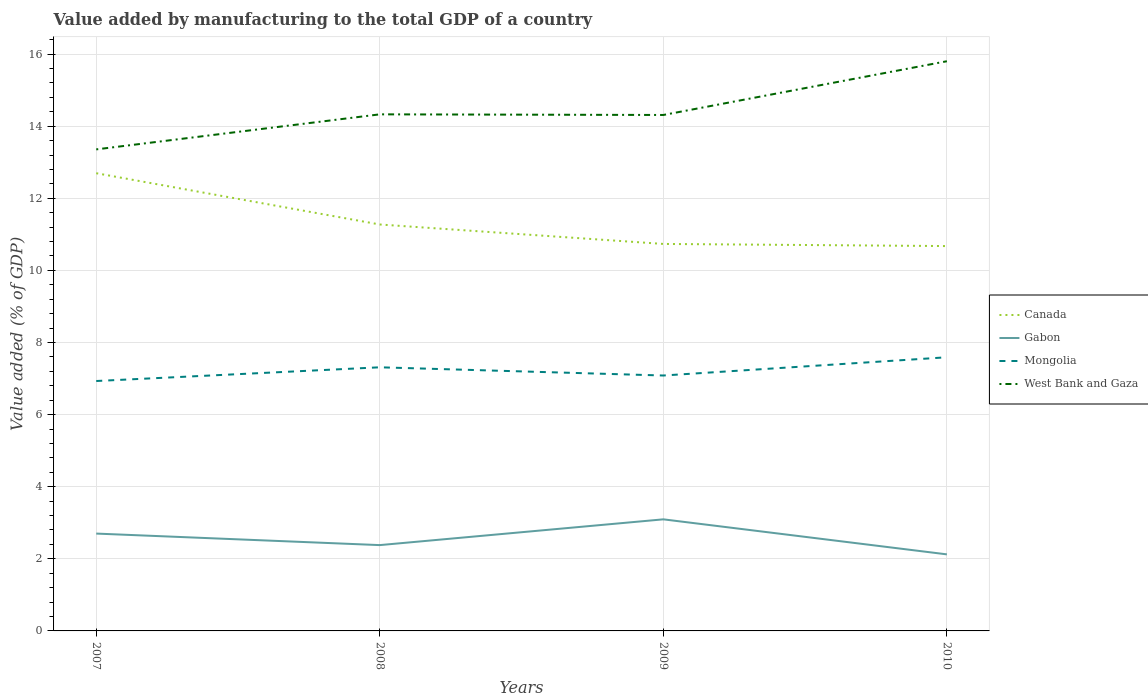How many different coloured lines are there?
Offer a terse response. 4. Across all years, what is the maximum value added by manufacturing to the total GDP in West Bank and Gaza?
Offer a very short reply. 13.36. In which year was the value added by manufacturing to the total GDP in Mongolia maximum?
Make the answer very short. 2007. What is the total value added by manufacturing to the total GDP in West Bank and Gaza in the graph?
Ensure brevity in your answer.  -2.45. What is the difference between the highest and the second highest value added by manufacturing to the total GDP in Gabon?
Ensure brevity in your answer.  0.97. What is the difference between the highest and the lowest value added by manufacturing to the total GDP in West Bank and Gaza?
Your response must be concise. 1. Is the value added by manufacturing to the total GDP in Canada strictly greater than the value added by manufacturing to the total GDP in West Bank and Gaza over the years?
Offer a terse response. Yes. Does the graph contain any zero values?
Offer a very short reply. No. How many legend labels are there?
Your response must be concise. 4. How are the legend labels stacked?
Make the answer very short. Vertical. What is the title of the graph?
Ensure brevity in your answer.  Value added by manufacturing to the total GDP of a country. Does "Tuvalu" appear as one of the legend labels in the graph?
Your answer should be compact. No. What is the label or title of the X-axis?
Give a very brief answer. Years. What is the label or title of the Y-axis?
Your answer should be very brief. Value added (% of GDP). What is the Value added (% of GDP) of Canada in 2007?
Your answer should be compact. 12.7. What is the Value added (% of GDP) of Gabon in 2007?
Offer a terse response. 2.7. What is the Value added (% of GDP) in Mongolia in 2007?
Your response must be concise. 6.93. What is the Value added (% of GDP) of West Bank and Gaza in 2007?
Provide a short and direct response. 13.36. What is the Value added (% of GDP) of Canada in 2008?
Ensure brevity in your answer.  11.27. What is the Value added (% of GDP) of Gabon in 2008?
Provide a short and direct response. 2.38. What is the Value added (% of GDP) in Mongolia in 2008?
Make the answer very short. 7.31. What is the Value added (% of GDP) in West Bank and Gaza in 2008?
Offer a very short reply. 14.33. What is the Value added (% of GDP) of Canada in 2009?
Make the answer very short. 10.73. What is the Value added (% of GDP) in Gabon in 2009?
Give a very brief answer. 3.1. What is the Value added (% of GDP) in Mongolia in 2009?
Make the answer very short. 7.08. What is the Value added (% of GDP) in West Bank and Gaza in 2009?
Give a very brief answer. 14.31. What is the Value added (% of GDP) of Canada in 2010?
Make the answer very short. 10.68. What is the Value added (% of GDP) in Gabon in 2010?
Keep it short and to the point. 2.12. What is the Value added (% of GDP) in Mongolia in 2010?
Provide a short and direct response. 7.59. What is the Value added (% of GDP) of West Bank and Gaza in 2010?
Provide a short and direct response. 15.8. Across all years, what is the maximum Value added (% of GDP) of Canada?
Your response must be concise. 12.7. Across all years, what is the maximum Value added (% of GDP) in Gabon?
Offer a very short reply. 3.1. Across all years, what is the maximum Value added (% of GDP) in Mongolia?
Offer a terse response. 7.59. Across all years, what is the maximum Value added (% of GDP) of West Bank and Gaza?
Offer a terse response. 15.8. Across all years, what is the minimum Value added (% of GDP) of Canada?
Make the answer very short. 10.68. Across all years, what is the minimum Value added (% of GDP) of Gabon?
Your response must be concise. 2.12. Across all years, what is the minimum Value added (% of GDP) of Mongolia?
Your answer should be very brief. 6.93. Across all years, what is the minimum Value added (% of GDP) in West Bank and Gaza?
Offer a terse response. 13.36. What is the total Value added (% of GDP) of Canada in the graph?
Offer a very short reply. 45.38. What is the total Value added (% of GDP) of Gabon in the graph?
Offer a very short reply. 10.3. What is the total Value added (% of GDP) of Mongolia in the graph?
Ensure brevity in your answer.  28.92. What is the total Value added (% of GDP) of West Bank and Gaza in the graph?
Keep it short and to the point. 57.8. What is the difference between the Value added (% of GDP) of Canada in 2007 and that in 2008?
Provide a short and direct response. 1.42. What is the difference between the Value added (% of GDP) of Gabon in 2007 and that in 2008?
Your answer should be compact. 0.32. What is the difference between the Value added (% of GDP) in Mongolia in 2007 and that in 2008?
Ensure brevity in your answer.  -0.38. What is the difference between the Value added (% of GDP) of West Bank and Gaza in 2007 and that in 2008?
Keep it short and to the point. -0.97. What is the difference between the Value added (% of GDP) of Canada in 2007 and that in 2009?
Offer a very short reply. 1.96. What is the difference between the Value added (% of GDP) of Gabon in 2007 and that in 2009?
Offer a terse response. -0.4. What is the difference between the Value added (% of GDP) in Mongolia in 2007 and that in 2009?
Provide a succinct answer. -0.15. What is the difference between the Value added (% of GDP) in West Bank and Gaza in 2007 and that in 2009?
Give a very brief answer. -0.95. What is the difference between the Value added (% of GDP) of Canada in 2007 and that in 2010?
Keep it short and to the point. 2.02. What is the difference between the Value added (% of GDP) of Gabon in 2007 and that in 2010?
Your answer should be very brief. 0.58. What is the difference between the Value added (% of GDP) of Mongolia in 2007 and that in 2010?
Offer a very short reply. -0.66. What is the difference between the Value added (% of GDP) of West Bank and Gaza in 2007 and that in 2010?
Offer a very short reply. -2.45. What is the difference between the Value added (% of GDP) of Canada in 2008 and that in 2009?
Offer a terse response. 0.54. What is the difference between the Value added (% of GDP) in Gabon in 2008 and that in 2009?
Ensure brevity in your answer.  -0.71. What is the difference between the Value added (% of GDP) of Mongolia in 2008 and that in 2009?
Provide a short and direct response. 0.23. What is the difference between the Value added (% of GDP) in West Bank and Gaza in 2008 and that in 2009?
Provide a short and direct response. 0.02. What is the difference between the Value added (% of GDP) of Canada in 2008 and that in 2010?
Make the answer very short. 0.6. What is the difference between the Value added (% of GDP) in Gabon in 2008 and that in 2010?
Ensure brevity in your answer.  0.26. What is the difference between the Value added (% of GDP) in Mongolia in 2008 and that in 2010?
Keep it short and to the point. -0.28. What is the difference between the Value added (% of GDP) in West Bank and Gaza in 2008 and that in 2010?
Your answer should be very brief. -1.47. What is the difference between the Value added (% of GDP) of Canada in 2009 and that in 2010?
Give a very brief answer. 0.06. What is the difference between the Value added (% of GDP) in Gabon in 2009 and that in 2010?
Offer a terse response. 0.97. What is the difference between the Value added (% of GDP) of Mongolia in 2009 and that in 2010?
Make the answer very short. -0.51. What is the difference between the Value added (% of GDP) of West Bank and Gaza in 2009 and that in 2010?
Offer a very short reply. -1.49. What is the difference between the Value added (% of GDP) of Canada in 2007 and the Value added (% of GDP) of Gabon in 2008?
Keep it short and to the point. 10.32. What is the difference between the Value added (% of GDP) of Canada in 2007 and the Value added (% of GDP) of Mongolia in 2008?
Your response must be concise. 5.38. What is the difference between the Value added (% of GDP) of Canada in 2007 and the Value added (% of GDP) of West Bank and Gaza in 2008?
Provide a succinct answer. -1.63. What is the difference between the Value added (% of GDP) of Gabon in 2007 and the Value added (% of GDP) of Mongolia in 2008?
Keep it short and to the point. -4.61. What is the difference between the Value added (% of GDP) in Gabon in 2007 and the Value added (% of GDP) in West Bank and Gaza in 2008?
Your answer should be compact. -11.63. What is the difference between the Value added (% of GDP) in Mongolia in 2007 and the Value added (% of GDP) in West Bank and Gaza in 2008?
Provide a succinct answer. -7.4. What is the difference between the Value added (% of GDP) in Canada in 2007 and the Value added (% of GDP) in Gabon in 2009?
Your answer should be very brief. 9.6. What is the difference between the Value added (% of GDP) in Canada in 2007 and the Value added (% of GDP) in Mongolia in 2009?
Make the answer very short. 5.61. What is the difference between the Value added (% of GDP) in Canada in 2007 and the Value added (% of GDP) in West Bank and Gaza in 2009?
Offer a terse response. -1.62. What is the difference between the Value added (% of GDP) of Gabon in 2007 and the Value added (% of GDP) of Mongolia in 2009?
Your answer should be compact. -4.38. What is the difference between the Value added (% of GDP) in Gabon in 2007 and the Value added (% of GDP) in West Bank and Gaza in 2009?
Your response must be concise. -11.61. What is the difference between the Value added (% of GDP) of Mongolia in 2007 and the Value added (% of GDP) of West Bank and Gaza in 2009?
Offer a terse response. -7.38. What is the difference between the Value added (% of GDP) in Canada in 2007 and the Value added (% of GDP) in Gabon in 2010?
Keep it short and to the point. 10.57. What is the difference between the Value added (% of GDP) in Canada in 2007 and the Value added (% of GDP) in Mongolia in 2010?
Your answer should be very brief. 5.11. What is the difference between the Value added (% of GDP) in Canada in 2007 and the Value added (% of GDP) in West Bank and Gaza in 2010?
Your response must be concise. -3.11. What is the difference between the Value added (% of GDP) of Gabon in 2007 and the Value added (% of GDP) of Mongolia in 2010?
Provide a short and direct response. -4.89. What is the difference between the Value added (% of GDP) of Gabon in 2007 and the Value added (% of GDP) of West Bank and Gaza in 2010?
Provide a succinct answer. -13.1. What is the difference between the Value added (% of GDP) in Mongolia in 2007 and the Value added (% of GDP) in West Bank and Gaza in 2010?
Keep it short and to the point. -8.87. What is the difference between the Value added (% of GDP) in Canada in 2008 and the Value added (% of GDP) in Gabon in 2009?
Ensure brevity in your answer.  8.18. What is the difference between the Value added (% of GDP) of Canada in 2008 and the Value added (% of GDP) of Mongolia in 2009?
Your response must be concise. 4.19. What is the difference between the Value added (% of GDP) of Canada in 2008 and the Value added (% of GDP) of West Bank and Gaza in 2009?
Provide a short and direct response. -3.04. What is the difference between the Value added (% of GDP) of Gabon in 2008 and the Value added (% of GDP) of Mongolia in 2009?
Keep it short and to the point. -4.7. What is the difference between the Value added (% of GDP) of Gabon in 2008 and the Value added (% of GDP) of West Bank and Gaza in 2009?
Give a very brief answer. -11.93. What is the difference between the Value added (% of GDP) in Mongolia in 2008 and the Value added (% of GDP) in West Bank and Gaza in 2009?
Keep it short and to the point. -7. What is the difference between the Value added (% of GDP) of Canada in 2008 and the Value added (% of GDP) of Gabon in 2010?
Provide a short and direct response. 9.15. What is the difference between the Value added (% of GDP) of Canada in 2008 and the Value added (% of GDP) of Mongolia in 2010?
Keep it short and to the point. 3.68. What is the difference between the Value added (% of GDP) of Canada in 2008 and the Value added (% of GDP) of West Bank and Gaza in 2010?
Provide a succinct answer. -4.53. What is the difference between the Value added (% of GDP) in Gabon in 2008 and the Value added (% of GDP) in Mongolia in 2010?
Ensure brevity in your answer.  -5.21. What is the difference between the Value added (% of GDP) of Gabon in 2008 and the Value added (% of GDP) of West Bank and Gaza in 2010?
Offer a terse response. -13.42. What is the difference between the Value added (% of GDP) of Mongolia in 2008 and the Value added (% of GDP) of West Bank and Gaza in 2010?
Your answer should be compact. -8.49. What is the difference between the Value added (% of GDP) in Canada in 2009 and the Value added (% of GDP) in Gabon in 2010?
Your answer should be compact. 8.61. What is the difference between the Value added (% of GDP) of Canada in 2009 and the Value added (% of GDP) of Mongolia in 2010?
Your answer should be very brief. 3.14. What is the difference between the Value added (% of GDP) in Canada in 2009 and the Value added (% of GDP) in West Bank and Gaza in 2010?
Your answer should be very brief. -5.07. What is the difference between the Value added (% of GDP) in Gabon in 2009 and the Value added (% of GDP) in Mongolia in 2010?
Your answer should be compact. -4.5. What is the difference between the Value added (% of GDP) in Gabon in 2009 and the Value added (% of GDP) in West Bank and Gaza in 2010?
Give a very brief answer. -12.71. What is the difference between the Value added (% of GDP) of Mongolia in 2009 and the Value added (% of GDP) of West Bank and Gaza in 2010?
Your answer should be compact. -8.72. What is the average Value added (% of GDP) in Canada per year?
Your answer should be very brief. 11.34. What is the average Value added (% of GDP) in Gabon per year?
Give a very brief answer. 2.57. What is the average Value added (% of GDP) in Mongolia per year?
Your response must be concise. 7.23. What is the average Value added (% of GDP) of West Bank and Gaza per year?
Offer a terse response. 14.45. In the year 2007, what is the difference between the Value added (% of GDP) of Canada and Value added (% of GDP) of Gabon?
Offer a very short reply. 10. In the year 2007, what is the difference between the Value added (% of GDP) in Canada and Value added (% of GDP) in Mongolia?
Offer a very short reply. 5.76. In the year 2007, what is the difference between the Value added (% of GDP) of Canada and Value added (% of GDP) of West Bank and Gaza?
Make the answer very short. -0.66. In the year 2007, what is the difference between the Value added (% of GDP) in Gabon and Value added (% of GDP) in Mongolia?
Ensure brevity in your answer.  -4.23. In the year 2007, what is the difference between the Value added (% of GDP) in Gabon and Value added (% of GDP) in West Bank and Gaza?
Keep it short and to the point. -10.66. In the year 2007, what is the difference between the Value added (% of GDP) of Mongolia and Value added (% of GDP) of West Bank and Gaza?
Make the answer very short. -6.42. In the year 2008, what is the difference between the Value added (% of GDP) of Canada and Value added (% of GDP) of Gabon?
Provide a succinct answer. 8.89. In the year 2008, what is the difference between the Value added (% of GDP) of Canada and Value added (% of GDP) of Mongolia?
Your answer should be compact. 3.96. In the year 2008, what is the difference between the Value added (% of GDP) in Canada and Value added (% of GDP) in West Bank and Gaza?
Your answer should be compact. -3.06. In the year 2008, what is the difference between the Value added (% of GDP) in Gabon and Value added (% of GDP) in Mongolia?
Keep it short and to the point. -4.93. In the year 2008, what is the difference between the Value added (% of GDP) in Gabon and Value added (% of GDP) in West Bank and Gaza?
Your answer should be very brief. -11.95. In the year 2008, what is the difference between the Value added (% of GDP) of Mongolia and Value added (% of GDP) of West Bank and Gaza?
Your answer should be very brief. -7.02. In the year 2009, what is the difference between the Value added (% of GDP) in Canada and Value added (% of GDP) in Gabon?
Your answer should be compact. 7.64. In the year 2009, what is the difference between the Value added (% of GDP) in Canada and Value added (% of GDP) in Mongolia?
Offer a terse response. 3.65. In the year 2009, what is the difference between the Value added (% of GDP) of Canada and Value added (% of GDP) of West Bank and Gaza?
Your answer should be very brief. -3.58. In the year 2009, what is the difference between the Value added (% of GDP) of Gabon and Value added (% of GDP) of Mongolia?
Your response must be concise. -3.99. In the year 2009, what is the difference between the Value added (% of GDP) of Gabon and Value added (% of GDP) of West Bank and Gaza?
Your response must be concise. -11.22. In the year 2009, what is the difference between the Value added (% of GDP) in Mongolia and Value added (% of GDP) in West Bank and Gaza?
Your answer should be very brief. -7.23. In the year 2010, what is the difference between the Value added (% of GDP) in Canada and Value added (% of GDP) in Gabon?
Offer a terse response. 8.55. In the year 2010, what is the difference between the Value added (% of GDP) of Canada and Value added (% of GDP) of Mongolia?
Provide a succinct answer. 3.08. In the year 2010, what is the difference between the Value added (% of GDP) of Canada and Value added (% of GDP) of West Bank and Gaza?
Give a very brief answer. -5.13. In the year 2010, what is the difference between the Value added (% of GDP) of Gabon and Value added (% of GDP) of Mongolia?
Ensure brevity in your answer.  -5.47. In the year 2010, what is the difference between the Value added (% of GDP) in Gabon and Value added (% of GDP) in West Bank and Gaza?
Offer a terse response. -13.68. In the year 2010, what is the difference between the Value added (% of GDP) in Mongolia and Value added (% of GDP) in West Bank and Gaza?
Offer a very short reply. -8.21. What is the ratio of the Value added (% of GDP) in Canada in 2007 to that in 2008?
Offer a very short reply. 1.13. What is the ratio of the Value added (% of GDP) of Gabon in 2007 to that in 2008?
Offer a terse response. 1.13. What is the ratio of the Value added (% of GDP) of Mongolia in 2007 to that in 2008?
Provide a short and direct response. 0.95. What is the ratio of the Value added (% of GDP) in West Bank and Gaza in 2007 to that in 2008?
Provide a short and direct response. 0.93. What is the ratio of the Value added (% of GDP) of Canada in 2007 to that in 2009?
Offer a terse response. 1.18. What is the ratio of the Value added (% of GDP) of Gabon in 2007 to that in 2009?
Your response must be concise. 0.87. What is the ratio of the Value added (% of GDP) in Mongolia in 2007 to that in 2009?
Offer a very short reply. 0.98. What is the ratio of the Value added (% of GDP) of Canada in 2007 to that in 2010?
Provide a succinct answer. 1.19. What is the ratio of the Value added (% of GDP) in Gabon in 2007 to that in 2010?
Ensure brevity in your answer.  1.27. What is the ratio of the Value added (% of GDP) of Mongolia in 2007 to that in 2010?
Provide a short and direct response. 0.91. What is the ratio of the Value added (% of GDP) in West Bank and Gaza in 2007 to that in 2010?
Offer a terse response. 0.85. What is the ratio of the Value added (% of GDP) of Canada in 2008 to that in 2009?
Offer a terse response. 1.05. What is the ratio of the Value added (% of GDP) in Gabon in 2008 to that in 2009?
Keep it short and to the point. 0.77. What is the ratio of the Value added (% of GDP) in Mongolia in 2008 to that in 2009?
Offer a very short reply. 1.03. What is the ratio of the Value added (% of GDP) of Canada in 2008 to that in 2010?
Your response must be concise. 1.06. What is the ratio of the Value added (% of GDP) of Gabon in 2008 to that in 2010?
Ensure brevity in your answer.  1.12. What is the ratio of the Value added (% of GDP) of Mongolia in 2008 to that in 2010?
Keep it short and to the point. 0.96. What is the ratio of the Value added (% of GDP) of West Bank and Gaza in 2008 to that in 2010?
Offer a terse response. 0.91. What is the ratio of the Value added (% of GDP) of Canada in 2009 to that in 2010?
Ensure brevity in your answer.  1.01. What is the ratio of the Value added (% of GDP) of Gabon in 2009 to that in 2010?
Give a very brief answer. 1.46. What is the ratio of the Value added (% of GDP) in West Bank and Gaza in 2009 to that in 2010?
Your answer should be compact. 0.91. What is the difference between the highest and the second highest Value added (% of GDP) in Canada?
Your response must be concise. 1.42. What is the difference between the highest and the second highest Value added (% of GDP) of Gabon?
Your answer should be very brief. 0.4. What is the difference between the highest and the second highest Value added (% of GDP) of Mongolia?
Keep it short and to the point. 0.28. What is the difference between the highest and the second highest Value added (% of GDP) of West Bank and Gaza?
Your answer should be compact. 1.47. What is the difference between the highest and the lowest Value added (% of GDP) in Canada?
Keep it short and to the point. 2.02. What is the difference between the highest and the lowest Value added (% of GDP) in Gabon?
Provide a short and direct response. 0.97. What is the difference between the highest and the lowest Value added (% of GDP) in Mongolia?
Offer a terse response. 0.66. What is the difference between the highest and the lowest Value added (% of GDP) of West Bank and Gaza?
Give a very brief answer. 2.45. 